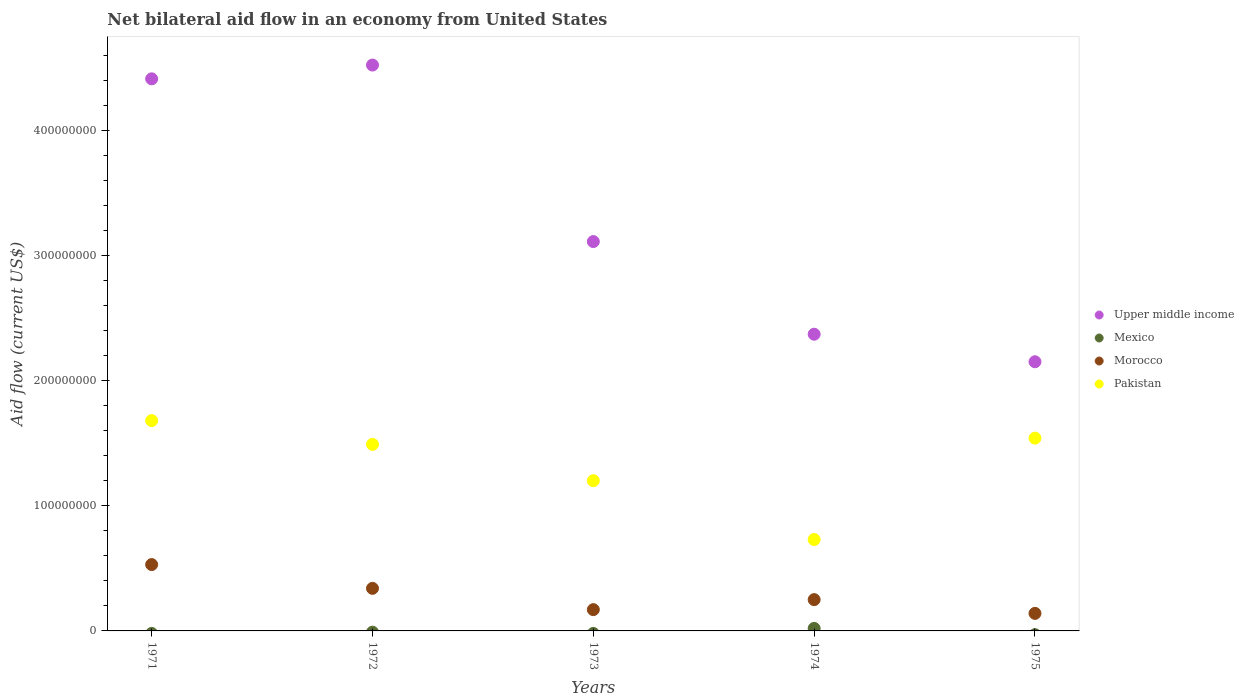How many different coloured dotlines are there?
Ensure brevity in your answer.  4. What is the net bilateral aid flow in Pakistan in 1975?
Offer a terse response. 1.54e+08. Across all years, what is the maximum net bilateral aid flow in Pakistan?
Provide a succinct answer. 1.68e+08. Across all years, what is the minimum net bilateral aid flow in Pakistan?
Ensure brevity in your answer.  7.30e+07. In which year was the net bilateral aid flow in Mexico maximum?
Your answer should be very brief. 1974. What is the total net bilateral aid flow in Morocco in the graph?
Provide a short and direct response. 1.43e+08. What is the difference between the net bilateral aid flow in Pakistan in 1972 and that in 1974?
Offer a very short reply. 7.60e+07. What is the difference between the net bilateral aid flow in Morocco in 1971 and the net bilateral aid flow in Pakistan in 1975?
Your answer should be compact. -1.01e+08. What is the average net bilateral aid flow in Pakistan per year?
Your answer should be compact. 1.33e+08. In the year 1973, what is the difference between the net bilateral aid flow in Upper middle income and net bilateral aid flow in Pakistan?
Keep it short and to the point. 1.91e+08. What is the ratio of the net bilateral aid flow in Pakistan in 1971 to that in 1972?
Your answer should be compact. 1.13. Is the difference between the net bilateral aid flow in Upper middle income in 1971 and 1975 greater than the difference between the net bilateral aid flow in Pakistan in 1971 and 1975?
Keep it short and to the point. Yes. What is the difference between the highest and the second highest net bilateral aid flow in Upper middle income?
Your response must be concise. 1.10e+07. What is the difference between the highest and the lowest net bilateral aid flow in Mexico?
Provide a succinct answer. 2.00e+06. Does the net bilateral aid flow in Morocco monotonically increase over the years?
Your answer should be very brief. No. Is the net bilateral aid flow in Upper middle income strictly greater than the net bilateral aid flow in Pakistan over the years?
Give a very brief answer. Yes. Is the net bilateral aid flow in Morocco strictly less than the net bilateral aid flow in Pakistan over the years?
Keep it short and to the point. Yes. How many dotlines are there?
Offer a terse response. 4. How many years are there in the graph?
Your answer should be very brief. 5. What is the difference between two consecutive major ticks on the Y-axis?
Make the answer very short. 1.00e+08. Does the graph contain grids?
Your answer should be compact. No. Where does the legend appear in the graph?
Offer a very short reply. Center right. How many legend labels are there?
Make the answer very short. 4. What is the title of the graph?
Keep it short and to the point. Net bilateral aid flow in an economy from United States. Does "Sudan" appear as one of the legend labels in the graph?
Offer a very short reply. No. What is the label or title of the X-axis?
Keep it short and to the point. Years. What is the label or title of the Y-axis?
Ensure brevity in your answer.  Aid flow (current US$). What is the Aid flow (current US$) of Upper middle income in 1971?
Ensure brevity in your answer.  4.41e+08. What is the Aid flow (current US$) in Morocco in 1971?
Your answer should be very brief. 5.30e+07. What is the Aid flow (current US$) in Pakistan in 1971?
Offer a very short reply. 1.68e+08. What is the Aid flow (current US$) of Upper middle income in 1972?
Ensure brevity in your answer.  4.52e+08. What is the Aid flow (current US$) of Morocco in 1972?
Your response must be concise. 3.40e+07. What is the Aid flow (current US$) of Pakistan in 1972?
Your response must be concise. 1.49e+08. What is the Aid flow (current US$) in Upper middle income in 1973?
Your answer should be compact. 3.11e+08. What is the Aid flow (current US$) of Morocco in 1973?
Provide a succinct answer. 1.70e+07. What is the Aid flow (current US$) in Pakistan in 1973?
Keep it short and to the point. 1.20e+08. What is the Aid flow (current US$) in Upper middle income in 1974?
Offer a terse response. 2.37e+08. What is the Aid flow (current US$) of Morocco in 1974?
Your response must be concise. 2.50e+07. What is the Aid flow (current US$) in Pakistan in 1974?
Keep it short and to the point. 7.30e+07. What is the Aid flow (current US$) in Upper middle income in 1975?
Provide a succinct answer. 2.15e+08. What is the Aid flow (current US$) in Mexico in 1975?
Your answer should be very brief. 0. What is the Aid flow (current US$) of Morocco in 1975?
Your response must be concise. 1.40e+07. What is the Aid flow (current US$) of Pakistan in 1975?
Keep it short and to the point. 1.54e+08. Across all years, what is the maximum Aid flow (current US$) of Upper middle income?
Ensure brevity in your answer.  4.52e+08. Across all years, what is the maximum Aid flow (current US$) of Morocco?
Your answer should be very brief. 5.30e+07. Across all years, what is the maximum Aid flow (current US$) of Pakistan?
Keep it short and to the point. 1.68e+08. Across all years, what is the minimum Aid flow (current US$) in Upper middle income?
Your response must be concise. 2.15e+08. Across all years, what is the minimum Aid flow (current US$) in Mexico?
Make the answer very short. 0. Across all years, what is the minimum Aid flow (current US$) of Morocco?
Offer a very short reply. 1.40e+07. Across all years, what is the minimum Aid flow (current US$) of Pakistan?
Offer a terse response. 7.30e+07. What is the total Aid flow (current US$) in Upper middle income in the graph?
Offer a very short reply. 1.66e+09. What is the total Aid flow (current US$) in Morocco in the graph?
Give a very brief answer. 1.43e+08. What is the total Aid flow (current US$) of Pakistan in the graph?
Make the answer very short. 6.64e+08. What is the difference between the Aid flow (current US$) of Upper middle income in 1971 and that in 1972?
Offer a very short reply. -1.10e+07. What is the difference between the Aid flow (current US$) in Morocco in 1971 and that in 1972?
Offer a terse response. 1.90e+07. What is the difference between the Aid flow (current US$) in Pakistan in 1971 and that in 1972?
Offer a terse response. 1.90e+07. What is the difference between the Aid flow (current US$) of Upper middle income in 1971 and that in 1973?
Your answer should be very brief. 1.30e+08. What is the difference between the Aid flow (current US$) in Morocco in 1971 and that in 1973?
Provide a short and direct response. 3.60e+07. What is the difference between the Aid flow (current US$) in Pakistan in 1971 and that in 1973?
Your response must be concise. 4.80e+07. What is the difference between the Aid flow (current US$) of Upper middle income in 1971 and that in 1974?
Ensure brevity in your answer.  2.04e+08. What is the difference between the Aid flow (current US$) of Morocco in 1971 and that in 1974?
Offer a terse response. 2.80e+07. What is the difference between the Aid flow (current US$) in Pakistan in 1971 and that in 1974?
Offer a terse response. 9.50e+07. What is the difference between the Aid flow (current US$) of Upper middle income in 1971 and that in 1975?
Keep it short and to the point. 2.26e+08. What is the difference between the Aid flow (current US$) of Morocco in 1971 and that in 1975?
Ensure brevity in your answer.  3.90e+07. What is the difference between the Aid flow (current US$) of Pakistan in 1971 and that in 1975?
Keep it short and to the point. 1.40e+07. What is the difference between the Aid flow (current US$) in Upper middle income in 1972 and that in 1973?
Offer a terse response. 1.41e+08. What is the difference between the Aid flow (current US$) in Morocco in 1972 and that in 1973?
Make the answer very short. 1.70e+07. What is the difference between the Aid flow (current US$) of Pakistan in 1972 and that in 1973?
Your answer should be compact. 2.90e+07. What is the difference between the Aid flow (current US$) in Upper middle income in 1972 and that in 1974?
Provide a succinct answer. 2.15e+08. What is the difference between the Aid flow (current US$) of Morocco in 1972 and that in 1974?
Offer a very short reply. 9.00e+06. What is the difference between the Aid flow (current US$) of Pakistan in 1972 and that in 1974?
Offer a very short reply. 7.60e+07. What is the difference between the Aid flow (current US$) of Upper middle income in 1972 and that in 1975?
Make the answer very short. 2.37e+08. What is the difference between the Aid flow (current US$) of Pakistan in 1972 and that in 1975?
Give a very brief answer. -5.00e+06. What is the difference between the Aid flow (current US$) of Upper middle income in 1973 and that in 1974?
Your response must be concise. 7.40e+07. What is the difference between the Aid flow (current US$) of Morocco in 1973 and that in 1974?
Your answer should be very brief. -8.00e+06. What is the difference between the Aid flow (current US$) of Pakistan in 1973 and that in 1974?
Make the answer very short. 4.70e+07. What is the difference between the Aid flow (current US$) of Upper middle income in 1973 and that in 1975?
Your answer should be very brief. 9.60e+07. What is the difference between the Aid flow (current US$) in Morocco in 1973 and that in 1975?
Your answer should be compact. 3.00e+06. What is the difference between the Aid flow (current US$) of Pakistan in 1973 and that in 1975?
Make the answer very short. -3.40e+07. What is the difference between the Aid flow (current US$) in Upper middle income in 1974 and that in 1975?
Offer a very short reply. 2.20e+07. What is the difference between the Aid flow (current US$) in Morocco in 1974 and that in 1975?
Make the answer very short. 1.10e+07. What is the difference between the Aid flow (current US$) in Pakistan in 1974 and that in 1975?
Your answer should be compact. -8.10e+07. What is the difference between the Aid flow (current US$) of Upper middle income in 1971 and the Aid flow (current US$) of Morocco in 1972?
Keep it short and to the point. 4.07e+08. What is the difference between the Aid flow (current US$) of Upper middle income in 1971 and the Aid flow (current US$) of Pakistan in 1972?
Your answer should be compact. 2.92e+08. What is the difference between the Aid flow (current US$) in Morocco in 1971 and the Aid flow (current US$) in Pakistan in 1972?
Provide a succinct answer. -9.60e+07. What is the difference between the Aid flow (current US$) of Upper middle income in 1971 and the Aid flow (current US$) of Morocco in 1973?
Your answer should be very brief. 4.24e+08. What is the difference between the Aid flow (current US$) of Upper middle income in 1971 and the Aid flow (current US$) of Pakistan in 1973?
Offer a terse response. 3.21e+08. What is the difference between the Aid flow (current US$) of Morocco in 1971 and the Aid flow (current US$) of Pakistan in 1973?
Make the answer very short. -6.70e+07. What is the difference between the Aid flow (current US$) in Upper middle income in 1971 and the Aid flow (current US$) in Mexico in 1974?
Offer a very short reply. 4.39e+08. What is the difference between the Aid flow (current US$) of Upper middle income in 1971 and the Aid flow (current US$) of Morocco in 1974?
Offer a terse response. 4.16e+08. What is the difference between the Aid flow (current US$) of Upper middle income in 1971 and the Aid flow (current US$) of Pakistan in 1974?
Your response must be concise. 3.68e+08. What is the difference between the Aid flow (current US$) of Morocco in 1971 and the Aid flow (current US$) of Pakistan in 1974?
Ensure brevity in your answer.  -2.00e+07. What is the difference between the Aid flow (current US$) in Upper middle income in 1971 and the Aid flow (current US$) in Morocco in 1975?
Provide a succinct answer. 4.27e+08. What is the difference between the Aid flow (current US$) in Upper middle income in 1971 and the Aid flow (current US$) in Pakistan in 1975?
Your answer should be very brief. 2.87e+08. What is the difference between the Aid flow (current US$) of Morocco in 1971 and the Aid flow (current US$) of Pakistan in 1975?
Your answer should be very brief. -1.01e+08. What is the difference between the Aid flow (current US$) of Upper middle income in 1972 and the Aid flow (current US$) of Morocco in 1973?
Offer a very short reply. 4.35e+08. What is the difference between the Aid flow (current US$) in Upper middle income in 1972 and the Aid flow (current US$) in Pakistan in 1973?
Offer a very short reply. 3.32e+08. What is the difference between the Aid flow (current US$) in Morocco in 1972 and the Aid flow (current US$) in Pakistan in 1973?
Provide a short and direct response. -8.60e+07. What is the difference between the Aid flow (current US$) in Upper middle income in 1972 and the Aid flow (current US$) in Mexico in 1974?
Ensure brevity in your answer.  4.50e+08. What is the difference between the Aid flow (current US$) in Upper middle income in 1972 and the Aid flow (current US$) in Morocco in 1974?
Keep it short and to the point. 4.27e+08. What is the difference between the Aid flow (current US$) of Upper middle income in 1972 and the Aid flow (current US$) of Pakistan in 1974?
Your answer should be compact. 3.79e+08. What is the difference between the Aid flow (current US$) in Morocco in 1972 and the Aid flow (current US$) in Pakistan in 1974?
Keep it short and to the point. -3.90e+07. What is the difference between the Aid flow (current US$) in Upper middle income in 1972 and the Aid flow (current US$) in Morocco in 1975?
Your response must be concise. 4.38e+08. What is the difference between the Aid flow (current US$) in Upper middle income in 1972 and the Aid flow (current US$) in Pakistan in 1975?
Your answer should be very brief. 2.98e+08. What is the difference between the Aid flow (current US$) of Morocco in 1972 and the Aid flow (current US$) of Pakistan in 1975?
Offer a very short reply. -1.20e+08. What is the difference between the Aid flow (current US$) in Upper middle income in 1973 and the Aid flow (current US$) in Mexico in 1974?
Make the answer very short. 3.09e+08. What is the difference between the Aid flow (current US$) of Upper middle income in 1973 and the Aid flow (current US$) of Morocco in 1974?
Offer a very short reply. 2.86e+08. What is the difference between the Aid flow (current US$) of Upper middle income in 1973 and the Aid flow (current US$) of Pakistan in 1974?
Give a very brief answer. 2.38e+08. What is the difference between the Aid flow (current US$) of Morocco in 1973 and the Aid flow (current US$) of Pakistan in 1974?
Your response must be concise. -5.60e+07. What is the difference between the Aid flow (current US$) of Upper middle income in 1973 and the Aid flow (current US$) of Morocco in 1975?
Provide a succinct answer. 2.97e+08. What is the difference between the Aid flow (current US$) of Upper middle income in 1973 and the Aid flow (current US$) of Pakistan in 1975?
Your answer should be compact. 1.57e+08. What is the difference between the Aid flow (current US$) of Morocco in 1973 and the Aid flow (current US$) of Pakistan in 1975?
Your answer should be very brief. -1.37e+08. What is the difference between the Aid flow (current US$) of Upper middle income in 1974 and the Aid flow (current US$) of Morocco in 1975?
Offer a very short reply. 2.23e+08. What is the difference between the Aid flow (current US$) of Upper middle income in 1974 and the Aid flow (current US$) of Pakistan in 1975?
Provide a short and direct response. 8.30e+07. What is the difference between the Aid flow (current US$) in Mexico in 1974 and the Aid flow (current US$) in Morocco in 1975?
Provide a succinct answer. -1.20e+07. What is the difference between the Aid flow (current US$) of Mexico in 1974 and the Aid flow (current US$) of Pakistan in 1975?
Your response must be concise. -1.52e+08. What is the difference between the Aid flow (current US$) in Morocco in 1974 and the Aid flow (current US$) in Pakistan in 1975?
Your answer should be compact. -1.29e+08. What is the average Aid flow (current US$) in Upper middle income per year?
Make the answer very short. 3.31e+08. What is the average Aid flow (current US$) of Mexico per year?
Offer a terse response. 4.00e+05. What is the average Aid flow (current US$) in Morocco per year?
Ensure brevity in your answer.  2.86e+07. What is the average Aid flow (current US$) of Pakistan per year?
Your answer should be compact. 1.33e+08. In the year 1971, what is the difference between the Aid flow (current US$) in Upper middle income and Aid flow (current US$) in Morocco?
Offer a very short reply. 3.88e+08. In the year 1971, what is the difference between the Aid flow (current US$) in Upper middle income and Aid flow (current US$) in Pakistan?
Your answer should be compact. 2.73e+08. In the year 1971, what is the difference between the Aid flow (current US$) of Morocco and Aid flow (current US$) of Pakistan?
Ensure brevity in your answer.  -1.15e+08. In the year 1972, what is the difference between the Aid flow (current US$) in Upper middle income and Aid flow (current US$) in Morocco?
Your answer should be compact. 4.18e+08. In the year 1972, what is the difference between the Aid flow (current US$) in Upper middle income and Aid flow (current US$) in Pakistan?
Your answer should be very brief. 3.03e+08. In the year 1972, what is the difference between the Aid flow (current US$) of Morocco and Aid flow (current US$) of Pakistan?
Your answer should be very brief. -1.15e+08. In the year 1973, what is the difference between the Aid flow (current US$) in Upper middle income and Aid flow (current US$) in Morocco?
Offer a very short reply. 2.94e+08. In the year 1973, what is the difference between the Aid flow (current US$) of Upper middle income and Aid flow (current US$) of Pakistan?
Keep it short and to the point. 1.91e+08. In the year 1973, what is the difference between the Aid flow (current US$) in Morocco and Aid flow (current US$) in Pakistan?
Keep it short and to the point. -1.03e+08. In the year 1974, what is the difference between the Aid flow (current US$) in Upper middle income and Aid flow (current US$) in Mexico?
Your response must be concise. 2.35e+08. In the year 1974, what is the difference between the Aid flow (current US$) of Upper middle income and Aid flow (current US$) of Morocco?
Your answer should be very brief. 2.12e+08. In the year 1974, what is the difference between the Aid flow (current US$) in Upper middle income and Aid flow (current US$) in Pakistan?
Provide a succinct answer. 1.64e+08. In the year 1974, what is the difference between the Aid flow (current US$) of Mexico and Aid flow (current US$) of Morocco?
Your answer should be compact. -2.30e+07. In the year 1974, what is the difference between the Aid flow (current US$) of Mexico and Aid flow (current US$) of Pakistan?
Offer a terse response. -7.10e+07. In the year 1974, what is the difference between the Aid flow (current US$) in Morocco and Aid flow (current US$) in Pakistan?
Your answer should be very brief. -4.80e+07. In the year 1975, what is the difference between the Aid flow (current US$) of Upper middle income and Aid flow (current US$) of Morocco?
Offer a terse response. 2.01e+08. In the year 1975, what is the difference between the Aid flow (current US$) in Upper middle income and Aid flow (current US$) in Pakistan?
Offer a very short reply. 6.10e+07. In the year 1975, what is the difference between the Aid flow (current US$) in Morocco and Aid flow (current US$) in Pakistan?
Keep it short and to the point. -1.40e+08. What is the ratio of the Aid flow (current US$) of Upper middle income in 1971 to that in 1972?
Keep it short and to the point. 0.98. What is the ratio of the Aid flow (current US$) in Morocco in 1971 to that in 1972?
Make the answer very short. 1.56. What is the ratio of the Aid flow (current US$) in Pakistan in 1971 to that in 1972?
Offer a very short reply. 1.13. What is the ratio of the Aid flow (current US$) of Upper middle income in 1971 to that in 1973?
Give a very brief answer. 1.42. What is the ratio of the Aid flow (current US$) in Morocco in 1971 to that in 1973?
Your answer should be compact. 3.12. What is the ratio of the Aid flow (current US$) of Pakistan in 1971 to that in 1973?
Your answer should be compact. 1.4. What is the ratio of the Aid flow (current US$) of Upper middle income in 1971 to that in 1974?
Your answer should be very brief. 1.86. What is the ratio of the Aid flow (current US$) of Morocco in 1971 to that in 1974?
Keep it short and to the point. 2.12. What is the ratio of the Aid flow (current US$) of Pakistan in 1971 to that in 1974?
Keep it short and to the point. 2.3. What is the ratio of the Aid flow (current US$) in Upper middle income in 1971 to that in 1975?
Your response must be concise. 2.05. What is the ratio of the Aid flow (current US$) in Morocco in 1971 to that in 1975?
Your response must be concise. 3.79. What is the ratio of the Aid flow (current US$) of Pakistan in 1971 to that in 1975?
Provide a short and direct response. 1.09. What is the ratio of the Aid flow (current US$) in Upper middle income in 1972 to that in 1973?
Offer a terse response. 1.45. What is the ratio of the Aid flow (current US$) in Morocco in 1972 to that in 1973?
Your answer should be very brief. 2. What is the ratio of the Aid flow (current US$) of Pakistan in 1972 to that in 1973?
Provide a short and direct response. 1.24. What is the ratio of the Aid flow (current US$) of Upper middle income in 1972 to that in 1974?
Offer a terse response. 1.91. What is the ratio of the Aid flow (current US$) of Morocco in 1972 to that in 1974?
Your answer should be very brief. 1.36. What is the ratio of the Aid flow (current US$) in Pakistan in 1972 to that in 1974?
Give a very brief answer. 2.04. What is the ratio of the Aid flow (current US$) in Upper middle income in 1972 to that in 1975?
Keep it short and to the point. 2.1. What is the ratio of the Aid flow (current US$) in Morocco in 1972 to that in 1975?
Your answer should be very brief. 2.43. What is the ratio of the Aid flow (current US$) of Pakistan in 1972 to that in 1975?
Your response must be concise. 0.97. What is the ratio of the Aid flow (current US$) in Upper middle income in 1973 to that in 1974?
Offer a very short reply. 1.31. What is the ratio of the Aid flow (current US$) in Morocco in 1973 to that in 1974?
Make the answer very short. 0.68. What is the ratio of the Aid flow (current US$) of Pakistan in 1973 to that in 1974?
Offer a very short reply. 1.64. What is the ratio of the Aid flow (current US$) in Upper middle income in 1973 to that in 1975?
Your answer should be compact. 1.45. What is the ratio of the Aid flow (current US$) in Morocco in 1973 to that in 1975?
Ensure brevity in your answer.  1.21. What is the ratio of the Aid flow (current US$) of Pakistan in 1973 to that in 1975?
Your answer should be very brief. 0.78. What is the ratio of the Aid flow (current US$) of Upper middle income in 1974 to that in 1975?
Provide a short and direct response. 1.1. What is the ratio of the Aid flow (current US$) in Morocco in 1974 to that in 1975?
Your answer should be very brief. 1.79. What is the ratio of the Aid flow (current US$) of Pakistan in 1974 to that in 1975?
Your response must be concise. 0.47. What is the difference between the highest and the second highest Aid flow (current US$) of Upper middle income?
Keep it short and to the point. 1.10e+07. What is the difference between the highest and the second highest Aid flow (current US$) in Morocco?
Your answer should be compact. 1.90e+07. What is the difference between the highest and the second highest Aid flow (current US$) in Pakistan?
Offer a very short reply. 1.40e+07. What is the difference between the highest and the lowest Aid flow (current US$) of Upper middle income?
Make the answer very short. 2.37e+08. What is the difference between the highest and the lowest Aid flow (current US$) in Morocco?
Your answer should be compact. 3.90e+07. What is the difference between the highest and the lowest Aid flow (current US$) in Pakistan?
Your answer should be compact. 9.50e+07. 